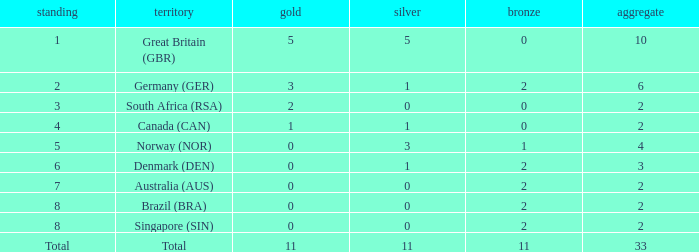What is the total when the nation is brazil (bra) and bronze is more than 2? None. 